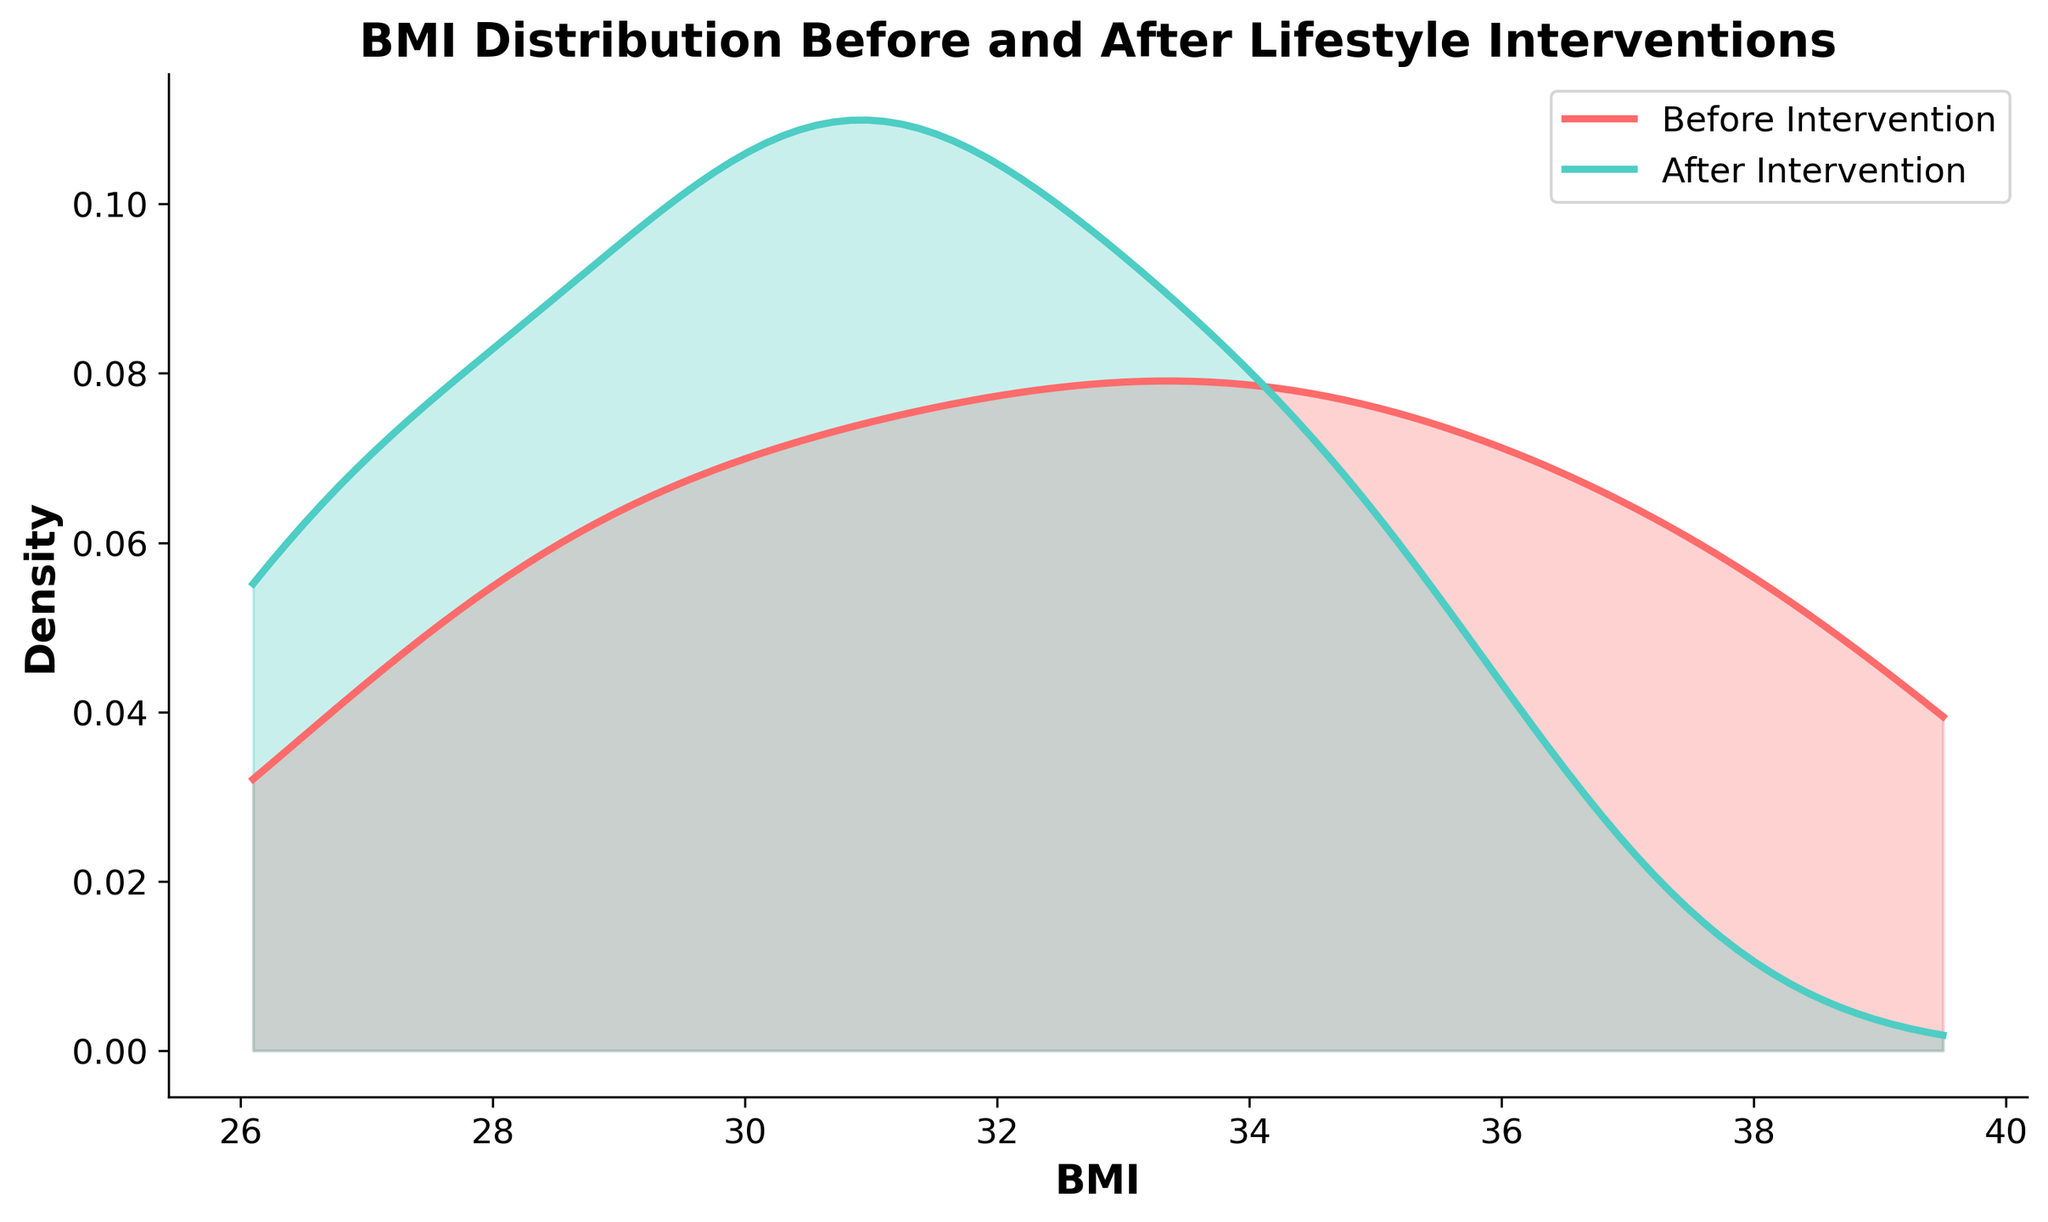What is the title of the figure? The title of the figure is usually found at the top center of the chart, indicating the subject or purpose of the chart.
Answer: BMI Distribution Before and After Lifestyle Interventions What do the x-axis and y-axis represent in the chart? The x-axis represents the BMI values, and the y-axis represents the density of these values. This information is typically labeled on the respective axes.
Answer: BMI and Density Which color represents the BMI distribution before the intervention? The color representing the BMI distribution before the intervention is indicated in the legend next to the corresponding label.
Answer: Red Which line is higher at BMI 30, before or after the intervention? To determine which is higher, look vertically at BMI 30 and compare the heights of the two lines.
Answer: Before the intervention What’s the general trend shown by the density plots from before to after the intervention? Analyze the overall shape and position of the two density plots to see if there is a noticeable shift. The plot after intervention generally moves to the left compared to the one before, indicating a reduction in BMI.
Answer: BMI generally decreases after intervention What does the area under the curve represent in a density plot? In a density plot, the area under the curve represents the probability distribution of the BMI values, with the total area summing up to 1.
Answer: Probability distribution How do the peaks of the two density plots compare in terms of location on the x-axis (BMI values)? Compare the locations of the highest points of the two curves along the x-axis. The peak of the after-intervention curve is shifted to the left compared to the before-intervention curve.
Answer: The peak after intervention is at a lower BMI value Is there a wider spread of BMI values before or after the intervention? To compare the spread, look at the width of the curves. The curve before intervention appears wider, indicating a larger variety of BMI values.
Answer: Before the intervention What is the approximate BMI range where the density of BMI is highest for the 'after intervention' group? Identify the x-axis range where the peak of the 'after intervention' density plot occurs.
Answer: Around 28-32 Based on the density plots, is it likely that the overall BMI of patients decreased after the lifestyle interventions? Examine the overall shift of the density plot from before to after intervention. The 'after intervention' plot is generally shifted to the left, indicating a decrease in BMI.
Answer: Yes 